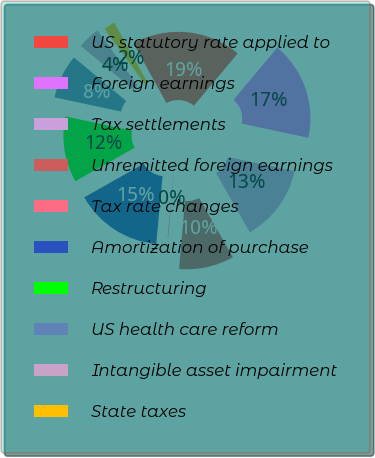<chart> <loc_0><loc_0><loc_500><loc_500><pie_chart><fcel>US statutory rate applied to<fcel>Foreign earnings<fcel>Tax settlements<fcel>Unremitted foreign earnings<fcel>Tax rate changes<fcel>Amortization of purchase<fcel>Restructuring<fcel>US health care reform<fcel>Intangible asset impairment<fcel>State taxes<nl><fcel>19.14%<fcel>17.24%<fcel>13.43%<fcel>9.62%<fcel>0.1%<fcel>15.33%<fcel>11.52%<fcel>7.72%<fcel>3.91%<fcel>2.0%<nl></chart> 